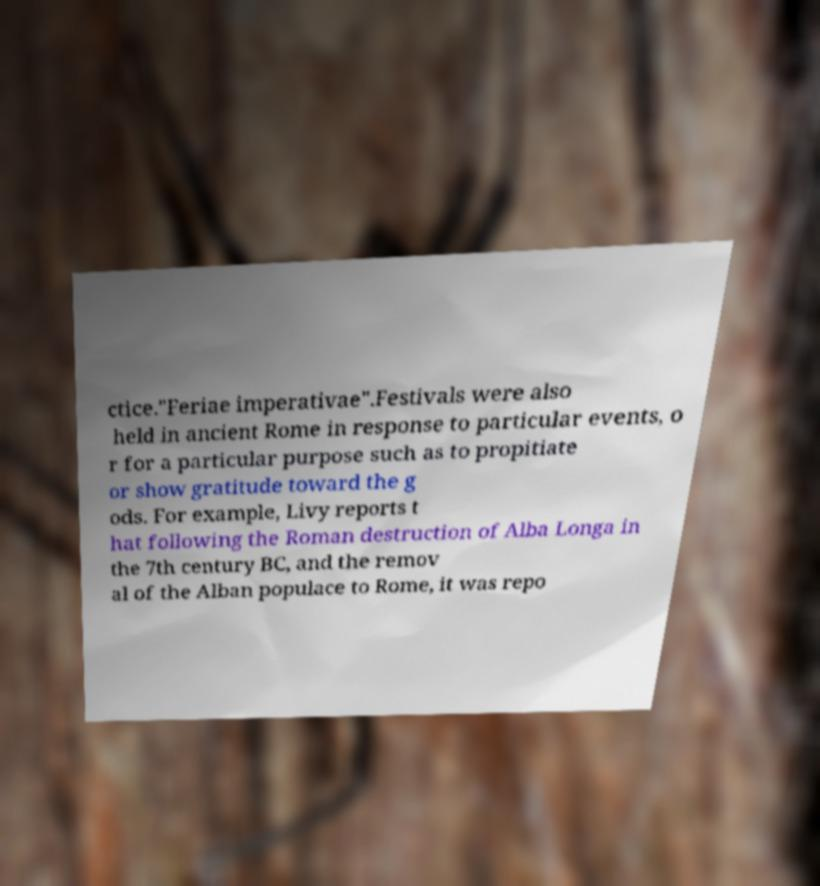Can you read and provide the text displayed in the image?This photo seems to have some interesting text. Can you extract and type it out for me? ctice."Feriae imperativae".Festivals were also held in ancient Rome in response to particular events, o r for a particular purpose such as to propitiate or show gratitude toward the g ods. For example, Livy reports t hat following the Roman destruction of Alba Longa in the 7th century BC, and the remov al of the Alban populace to Rome, it was repo 